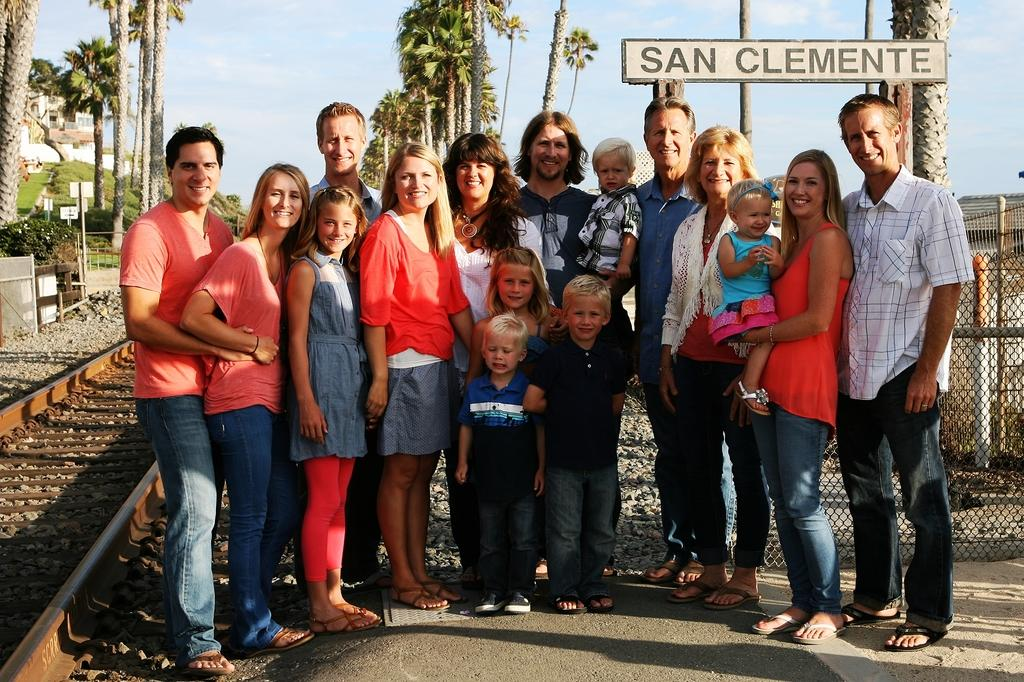How many people are present in the image? There are many people in the image. What can be seen at the bottom left of the image? There is a track at the bottom left of the image. What type of natural elements are visible in the background of the image? There are trees in the background of the image. What else can be seen in the background of the image? There is a board in the background of the image. What is visible at the top of the image? The sky is visible at the top of the image. What type of lumber is being used to construct the hill in the image? There is no hill present in the image, and therefore no lumber can be observed. What do the people in the image believe about the board in the background? The image does not provide any information about the beliefs of the people in the image, so it cannot be determined. 